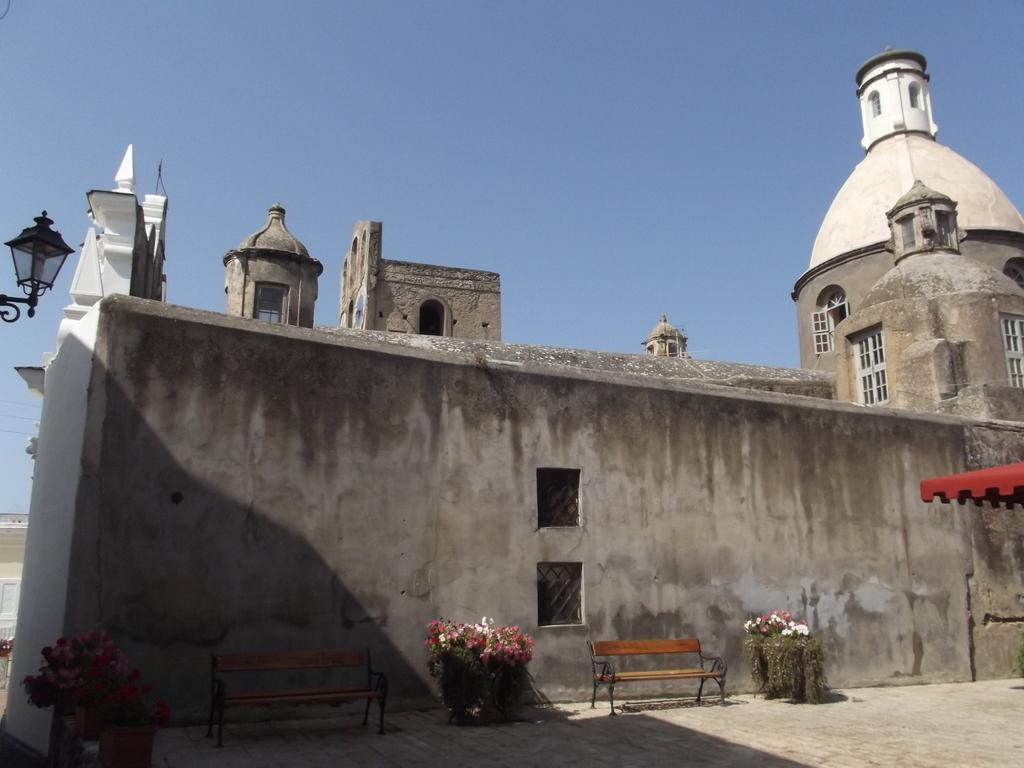What type of structure is in the image? There is a building in the image. What features can be seen on the building? The building has windows and benches on the wall. Are there any plants visible in the image? Yes, house plants are present on the wall. What can be seen on the left side of the image? There is a light on the left side of the image. What is visible in the background of the image? There is another building, electric wires, and the sky visible in the background. What type of quiver is hanging on the wall next to the house plants? There is no quiver present in the image; only benches and house plants are visible on the wall. What kind of food is being served for lunch in the image? There is no indication of food or lunch in the image. 